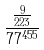<formula> <loc_0><loc_0><loc_500><loc_500>\frac { \frac { 9 } { 2 2 3 } } { 7 7 ^ { 4 5 5 } }</formula> 